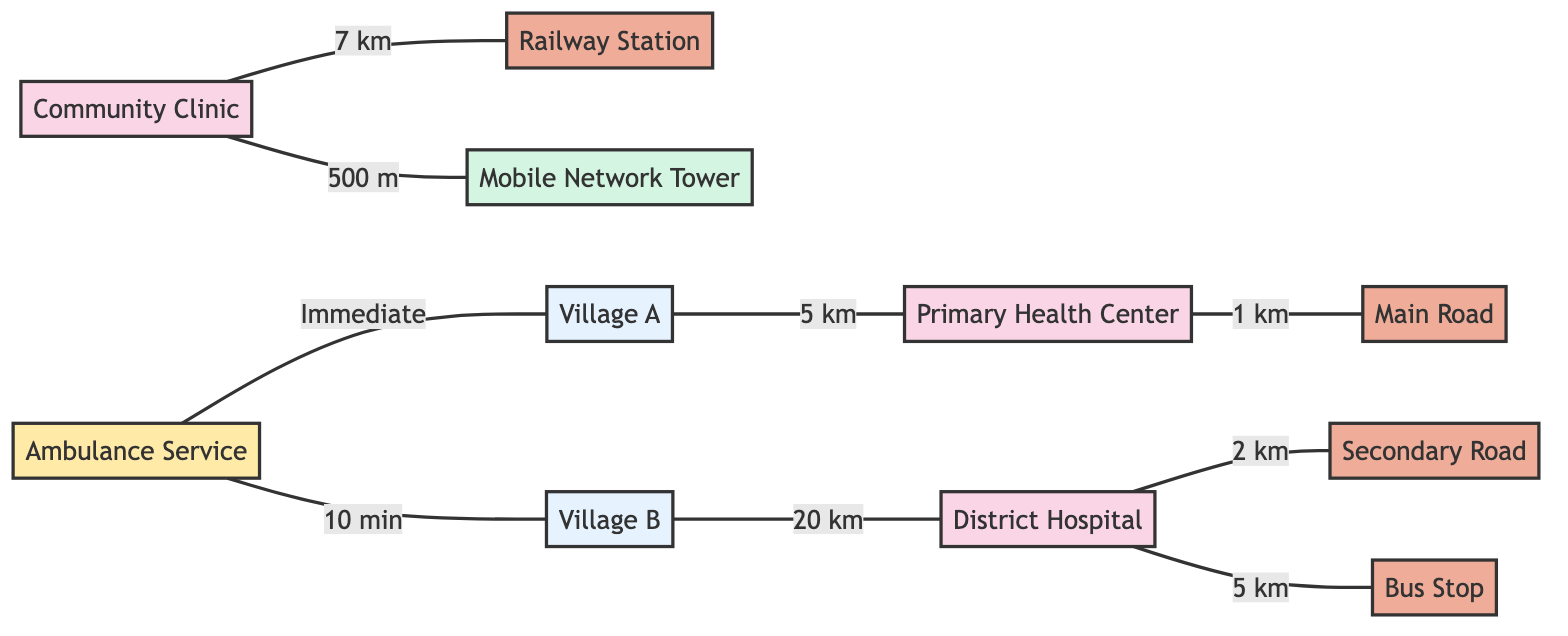What is the distance from Village A to the Primary Health Center? The edge between Village A and the Primary Health Center indicates a distance of 5 km.
Answer: 5 km How many healthcare facilities are shown in the diagram? The diagram displays three healthcare facilities: Primary Health Center, District Hospital, and Community Clinic.
Answer: 3 Which transport route is connected to the District Hospital? The District Hospital is connected to the Secondary Road, as indicated by the edge labeled as 2 km.
Answer: Secondary Road What is the closest public transport option to the Community Clinic? The Community Clinic is connected to the Railway Station by an edge that shows a distance of 7 km, indicating it's the closest public transport option among those listed.
Answer: Railway Station From which population center is the ambulance service available immediately? The ambulance service is indicated to be available immediately at Village A, as shown by the direct edge between the ambulance service and Village A.
Answer: Village A How far is the District Hospital from Village B? The diagram shows a distance of 20 km between Village B and the District Hospital, as depicted by the connecting edge.
Answer: 20 km What infrastructure is located closest to the Community Clinic? The Mobile Network Tower, which is at a distance of 500 m from the Community Clinic, represents the closest infrastructure.
Answer: Mobile Network Tower Which node has the longest distance connection to a population center? The District Hospital has the longest distance connection of 20 km to Village B, the farthest population center connected.
Answer: District Hospital What is the relationship between the Main Road and the Primary Health Center? The relationship is defined by an edge labeled as 1 km, indicating there is a direct connection with a specific distance.
Answer: 1 km 